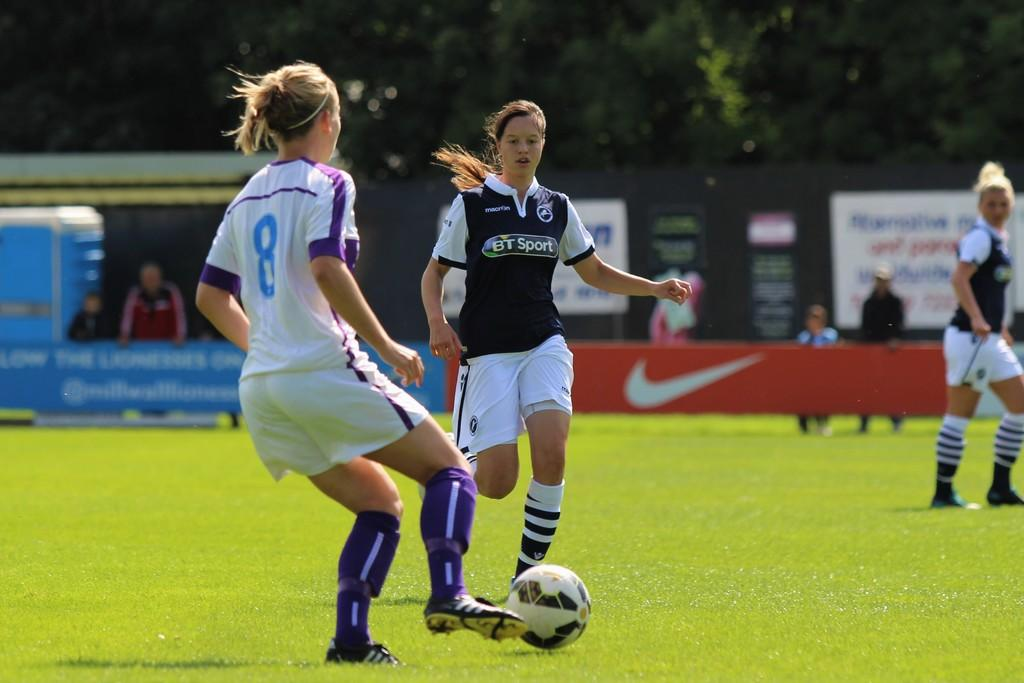<image>
Present a compact description of the photo's key features. soccer players playing on a field with one wearing a jersey that says "BT Sport". 